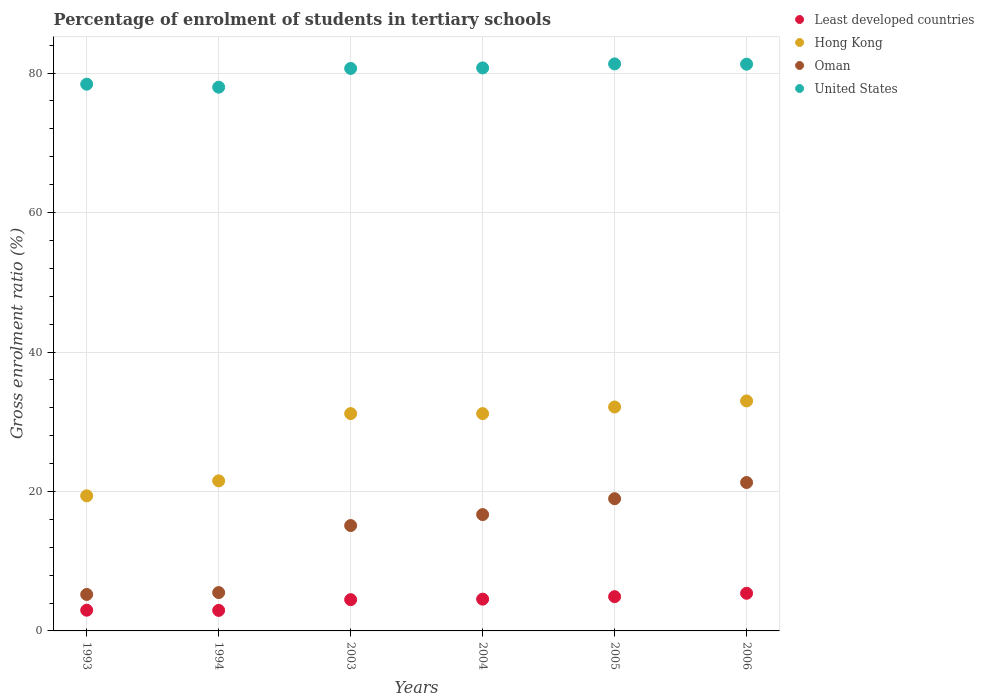How many different coloured dotlines are there?
Provide a succinct answer. 4. What is the percentage of students enrolled in tertiary schools in Least developed countries in 1993?
Make the answer very short. 2.97. Across all years, what is the maximum percentage of students enrolled in tertiary schools in United States?
Provide a succinct answer. 81.32. Across all years, what is the minimum percentage of students enrolled in tertiary schools in Oman?
Offer a terse response. 5.23. In which year was the percentage of students enrolled in tertiary schools in Hong Kong maximum?
Provide a succinct answer. 2006. In which year was the percentage of students enrolled in tertiary schools in Hong Kong minimum?
Provide a succinct answer. 1993. What is the total percentage of students enrolled in tertiary schools in United States in the graph?
Provide a short and direct response. 480.39. What is the difference between the percentage of students enrolled in tertiary schools in Least developed countries in 2003 and that in 2004?
Your response must be concise. -0.07. What is the difference between the percentage of students enrolled in tertiary schools in United States in 2006 and the percentage of students enrolled in tertiary schools in Hong Kong in 2004?
Give a very brief answer. 50.11. What is the average percentage of students enrolled in tertiary schools in Oman per year?
Ensure brevity in your answer.  13.79. In the year 2004, what is the difference between the percentage of students enrolled in tertiary schools in Least developed countries and percentage of students enrolled in tertiary schools in Hong Kong?
Keep it short and to the point. -26.61. In how many years, is the percentage of students enrolled in tertiary schools in Least developed countries greater than 4 %?
Your response must be concise. 4. What is the ratio of the percentage of students enrolled in tertiary schools in Oman in 2003 to that in 2006?
Your answer should be very brief. 0.71. Is the percentage of students enrolled in tertiary schools in Oman in 1993 less than that in 2006?
Your answer should be very brief. Yes. What is the difference between the highest and the second highest percentage of students enrolled in tertiary schools in Hong Kong?
Offer a very short reply. 0.87. What is the difference between the highest and the lowest percentage of students enrolled in tertiary schools in Least developed countries?
Ensure brevity in your answer.  2.46. In how many years, is the percentage of students enrolled in tertiary schools in Oman greater than the average percentage of students enrolled in tertiary schools in Oman taken over all years?
Your response must be concise. 4. Is the sum of the percentage of students enrolled in tertiary schools in Oman in 2003 and 2006 greater than the maximum percentage of students enrolled in tertiary schools in United States across all years?
Give a very brief answer. No. Does the percentage of students enrolled in tertiary schools in Hong Kong monotonically increase over the years?
Offer a terse response. No. Is the percentage of students enrolled in tertiary schools in Least developed countries strictly less than the percentage of students enrolled in tertiary schools in Oman over the years?
Your response must be concise. Yes. How many years are there in the graph?
Provide a short and direct response. 6. What is the difference between two consecutive major ticks on the Y-axis?
Your answer should be very brief. 20. Are the values on the major ticks of Y-axis written in scientific E-notation?
Your answer should be very brief. No. How are the legend labels stacked?
Your answer should be compact. Vertical. What is the title of the graph?
Offer a terse response. Percentage of enrolment of students in tertiary schools. What is the Gross enrolment ratio (%) in Least developed countries in 1993?
Provide a succinct answer. 2.97. What is the Gross enrolment ratio (%) of Hong Kong in 1993?
Provide a short and direct response. 19.37. What is the Gross enrolment ratio (%) in Oman in 1993?
Ensure brevity in your answer.  5.23. What is the Gross enrolment ratio (%) in United States in 1993?
Offer a very short reply. 78.41. What is the Gross enrolment ratio (%) in Least developed countries in 1994?
Your answer should be very brief. 2.94. What is the Gross enrolment ratio (%) of Hong Kong in 1994?
Make the answer very short. 21.52. What is the Gross enrolment ratio (%) in Oman in 1994?
Ensure brevity in your answer.  5.5. What is the Gross enrolment ratio (%) in United States in 1994?
Keep it short and to the point. 77.98. What is the Gross enrolment ratio (%) of Least developed countries in 2003?
Offer a very short reply. 4.48. What is the Gross enrolment ratio (%) of Hong Kong in 2003?
Give a very brief answer. 31.17. What is the Gross enrolment ratio (%) of Oman in 2003?
Provide a succinct answer. 15.11. What is the Gross enrolment ratio (%) in United States in 2003?
Your response must be concise. 80.66. What is the Gross enrolment ratio (%) in Least developed countries in 2004?
Offer a very short reply. 4.56. What is the Gross enrolment ratio (%) in Hong Kong in 2004?
Provide a short and direct response. 31.16. What is the Gross enrolment ratio (%) of Oman in 2004?
Offer a very short reply. 16.68. What is the Gross enrolment ratio (%) of United States in 2004?
Your response must be concise. 80.74. What is the Gross enrolment ratio (%) of Least developed countries in 2005?
Offer a terse response. 4.91. What is the Gross enrolment ratio (%) in Hong Kong in 2005?
Provide a short and direct response. 32.12. What is the Gross enrolment ratio (%) in Oman in 2005?
Offer a terse response. 18.96. What is the Gross enrolment ratio (%) in United States in 2005?
Give a very brief answer. 81.32. What is the Gross enrolment ratio (%) in Least developed countries in 2006?
Provide a short and direct response. 5.4. What is the Gross enrolment ratio (%) of Hong Kong in 2006?
Offer a very short reply. 32.98. What is the Gross enrolment ratio (%) of Oman in 2006?
Ensure brevity in your answer.  21.28. What is the Gross enrolment ratio (%) in United States in 2006?
Give a very brief answer. 81.28. Across all years, what is the maximum Gross enrolment ratio (%) in Least developed countries?
Your response must be concise. 5.4. Across all years, what is the maximum Gross enrolment ratio (%) of Hong Kong?
Give a very brief answer. 32.98. Across all years, what is the maximum Gross enrolment ratio (%) of Oman?
Offer a terse response. 21.28. Across all years, what is the maximum Gross enrolment ratio (%) in United States?
Your answer should be compact. 81.32. Across all years, what is the minimum Gross enrolment ratio (%) in Least developed countries?
Provide a short and direct response. 2.94. Across all years, what is the minimum Gross enrolment ratio (%) of Hong Kong?
Keep it short and to the point. 19.37. Across all years, what is the minimum Gross enrolment ratio (%) of Oman?
Provide a short and direct response. 5.23. Across all years, what is the minimum Gross enrolment ratio (%) in United States?
Your answer should be compact. 77.98. What is the total Gross enrolment ratio (%) of Least developed countries in the graph?
Give a very brief answer. 25.27. What is the total Gross enrolment ratio (%) of Hong Kong in the graph?
Make the answer very short. 168.33. What is the total Gross enrolment ratio (%) in Oman in the graph?
Your response must be concise. 82.77. What is the total Gross enrolment ratio (%) in United States in the graph?
Provide a short and direct response. 480.39. What is the difference between the Gross enrolment ratio (%) in Least developed countries in 1993 and that in 1994?
Provide a short and direct response. 0.03. What is the difference between the Gross enrolment ratio (%) in Hong Kong in 1993 and that in 1994?
Offer a terse response. -2.15. What is the difference between the Gross enrolment ratio (%) of Oman in 1993 and that in 1994?
Your answer should be compact. -0.27. What is the difference between the Gross enrolment ratio (%) of United States in 1993 and that in 1994?
Make the answer very short. 0.43. What is the difference between the Gross enrolment ratio (%) of Least developed countries in 1993 and that in 2003?
Make the answer very short. -1.51. What is the difference between the Gross enrolment ratio (%) of Hong Kong in 1993 and that in 2003?
Provide a succinct answer. -11.79. What is the difference between the Gross enrolment ratio (%) of Oman in 1993 and that in 2003?
Your answer should be compact. -9.88. What is the difference between the Gross enrolment ratio (%) of United States in 1993 and that in 2003?
Ensure brevity in your answer.  -2.25. What is the difference between the Gross enrolment ratio (%) in Least developed countries in 1993 and that in 2004?
Offer a terse response. -1.58. What is the difference between the Gross enrolment ratio (%) in Hong Kong in 1993 and that in 2004?
Your answer should be compact. -11.79. What is the difference between the Gross enrolment ratio (%) in Oman in 1993 and that in 2004?
Give a very brief answer. -11.45. What is the difference between the Gross enrolment ratio (%) of United States in 1993 and that in 2004?
Keep it short and to the point. -2.33. What is the difference between the Gross enrolment ratio (%) in Least developed countries in 1993 and that in 2005?
Offer a terse response. -1.94. What is the difference between the Gross enrolment ratio (%) of Hong Kong in 1993 and that in 2005?
Make the answer very short. -12.74. What is the difference between the Gross enrolment ratio (%) of Oman in 1993 and that in 2005?
Keep it short and to the point. -13.73. What is the difference between the Gross enrolment ratio (%) of United States in 1993 and that in 2005?
Offer a terse response. -2.91. What is the difference between the Gross enrolment ratio (%) in Least developed countries in 1993 and that in 2006?
Provide a succinct answer. -2.43. What is the difference between the Gross enrolment ratio (%) in Hong Kong in 1993 and that in 2006?
Offer a very short reply. -13.61. What is the difference between the Gross enrolment ratio (%) in Oman in 1993 and that in 2006?
Your response must be concise. -16.05. What is the difference between the Gross enrolment ratio (%) of United States in 1993 and that in 2006?
Offer a terse response. -2.87. What is the difference between the Gross enrolment ratio (%) in Least developed countries in 1994 and that in 2003?
Provide a short and direct response. -1.54. What is the difference between the Gross enrolment ratio (%) in Hong Kong in 1994 and that in 2003?
Offer a terse response. -9.65. What is the difference between the Gross enrolment ratio (%) of Oman in 1994 and that in 2003?
Keep it short and to the point. -9.61. What is the difference between the Gross enrolment ratio (%) of United States in 1994 and that in 2003?
Ensure brevity in your answer.  -2.69. What is the difference between the Gross enrolment ratio (%) of Least developed countries in 1994 and that in 2004?
Provide a succinct answer. -1.61. What is the difference between the Gross enrolment ratio (%) in Hong Kong in 1994 and that in 2004?
Give a very brief answer. -9.64. What is the difference between the Gross enrolment ratio (%) in Oman in 1994 and that in 2004?
Make the answer very short. -11.18. What is the difference between the Gross enrolment ratio (%) in United States in 1994 and that in 2004?
Keep it short and to the point. -2.76. What is the difference between the Gross enrolment ratio (%) of Least developed countries in 1994 and that in 2005?
Your answer should be compact. -1.97. What is the difference between the Gross enrolment ratio (%) in Hong Kong in 1994 and that in 2005?
Make the answer very short. -10.59. What is the difference between the Gross enrolment ratio (%) in Oman in 1994 and that in 2005?
Make the answer very short. -13.46. What is the difference between the Gross enrolment ratio (%) of United States in 1994 and that in 2005?
Make the answer very short. -3.34. What is the difference between the Gross enrolment ratio (%) of Least developed countries in 1994 and that in 2006?
Keep it short and to the point. -2.46. What is the difference between the Gross enrolment ratio (%) in Hong Kong in 1994 and that in 2006?
Make the answer very short. -11.46. What is the difference between the Gross enrolment ratio (%) in Oman in 1994 and that in 2006?
Give a very brief answer. -15.78. What is the difference between the Gross enrolment ratio (%) of United States in 1994 and that in 2006?
Your answer should be compact. -3.3. What is the difference between the Gross enrolment ratio (%) of Least developed countries in 2003 and that in 2004?
Provide a short and direct response. -0.07. What is the difference between the Gross enrolment ratio (%) of Hong Kong in 2003 and that in 2004?
Ensure brevity in your answer.  0. What is the difference between the Gross enrolment ratio (%) in Oman in 2003 and that in 2004?
Your response must be concise. -1.57. What is the difference between the Gross enrolment ratio (%) in United States in 2003 and that in 2004?
Make the answer very short. -0.08. What is the difference between the Gross enrolment ratio (%) in Least developed countries in 2003 and that in 2005?
Offer a terse response. -0.43. What is the difference between the Gross enrolment ratio (%) in Hong Kong in 2003 and that in 2005?
Your response must be concise. -0.95. What is the difference between the Gross enrolment ratio (%) of Oman in 2003 and that in 2005?
Offer a very short reply. -3.85. What is the difference between the Gross enrolment ratio (%) in United States in 2003 and that in 2005?
Offer a terse response. -0.65. What is the difference between the Gross enrolment ratio (%) of Least developed countries in 2003 and that in 2006?
Ensure brevity in your answer.  -0.92. What is the difference between the Gross enrolment ratio (%) of Hong Kong in 2003 and that in 2006?
Keep it short and to the point. -1.82. What is the difference between the Gross enrolment ratio (%) of Oman in 2003 and that in 2006?
Offer a terse response. -6.17. What is the difference between the Gross enrolment ratio (%) in United States in 2003 and that in 2006?
Offer a terse response. -0.61. What is the difference between the Gross enrolment ratio (%) in Least developed countries in 2004 and that in 2005?
Provide a short and direct response. -0.36. What is the difference between the Gross enrolment ratio (%) of Hong Kong in 2004 and that in 2005?
Offer a terse response. -0.95. What is the difference between the Gross enrolment ratio (%) of Oman in 2004 and that in 2005?
Your answer should be compact. -2.28. What is the difference between the Gross enrolment ratio (%) in United States in 2004 and that in 2005?
Make the answer very short. -0.57. What is the difference between the Gross enrolment ratio (%) in Least developed countries in 2004 and that in 2006?
Your answer should be compact. -0.84. What is the difference between the Gross enrolment ratio (%) in Hong Kong in 2004 and that in 2006?
Your answer should be very brief. -1.82. What is the difference between the Gross enrolment ratio (%) of Oman in 2004 and that in 2006?
Ensure brevity in your answer.  -4.6. What is the difference between the Gross enrolment ratio (%) of United States in 2004 and that in 2006?
Offer a terse response. -0.54. What is the difference between the Gross enrolment ratio (%) of Least developed countries in 2005 and that in 2006?
Provide a succinct answer. -0.49. What is the difference between the Gross enrolment ratio (%) in Hong Kong in 2005 and that in 2006?
Your answer should be compact. -0.87. What is the difference between the Gross enrolment ratio (%) in Oman in 2005 and that in 2006?
Your response must be concise. -2.32. What is the difference between the Gross enrolment ratio (%) in United States in 2005 and that in 2006?
Your response must be concise. 0.04. What is the difference between the Gross enrolment ratio (%) in Least developed countries in 1993 and the Gross enrolment ratio (%) in Hong Kong in 1994?
Ensure brevity in your answer.  -18.55. What is the difference between the Gross enrolment ratio (%) in Least developed countries in 1993 and the Gross enrolment ratio (%) in Oman in 1994?
Offer a very short reply. -2.53. What is the difference between the Gross enrolment ratio (%) in Least developed countries in 1993 and the Gross enrolment ratio (%) in United States in 1994?
Your answer should be very brief. -75.01. What is the difference between the Gross enrolment ratio (%) of Hong Kong in 1993 and the Gross enrolment ratio (%) of Oman in 1994?
Make the answer very short. 13.87. What is the difference between the Gross enrolment ratio (%) in Hong Kong in 1993 and the Gross enrolment ratio (%) in United States in 1994?
Provide a short and direct response. -58.6. What is the difference between the Gross enrolment ratio (%) in Oman in 1993 and the Gross enrolment ratio (%) in United States in 1994?
Provide a short and direct response. -72.75. What is the difference between the Gross enrolment ratio (%) in Least developed countries in 1993 and the Gross enrolment ratio (%) in Hong Kong in 2003?
Your answer should be very brief. -28.2. What is the difference between the Gross enrolment ratio (%) in Least developed countries in 1993 and the Gross enrolment ratio (%) in Oman in 2003?
Provide a succinct answer. -12.14. What is the difference between the Gross enrolment ratio (%) in Least developed countries in 1993 and the Gross enrolment ratio (%) in United States in 2003?
Ensure brevity in your answer.  -77.69. What is the difference between the Gross enrolment ratio (%) of Hong Kong in 1993 and the Gross enrolment ratio (%) of Oman in 2003?
Your answer should be very brief. 4.26. What is the difference between the Gross enrolment ratio (%) in Hong Kong in 1993 and the Gross enrolment ratio (%) in United States in 2003?
Provide a succinct answer. -61.29. What is the difference between the Gross enrolment ratio (%) of Oman in 1993 and the Gross enrolment ratio (%) of United States in 2003?
Keep it short and to the point. -75.43. What is the difference between the Gross enrolment ratio (%) of Least developed countries in 1993 and the Gross enrolment ratio (%) of Hong Kong in 2004?
Offer a terse response. -28.19. What is the difference between the Gross enrolment ratio (%) of Least developed countries in 1993 and the Gross enrolment ratio (%) of Oman in 2004?
Keep it short and to the point. -13.71. What is the difference between the Gross enrolment ratio (%) of Least developed countries in 1993 and the Gross enrolment ratio (%) of United States in 2004?
Your answer should be very brief. -77.77. What is the difference between the Gross enrolment ratio (%) in Hong Kong in 1993 and the Gross enrolment ratio (%) in Oman in 2004?
Make the answer very short. 2.69. What is the difference between the Gross enrolment ratio (%) of Hong Kong in 1993 and the Gross enrolment ratio (%) of United States in 2004?
Your response must be concise. -61.37. What is the difference between the Gross enrolment ratio (%) in Oman in 1993 and the Gross enrolment ratio (%) in United States in 2004?
Provide a short and direct response. -75.51. What is the difference between the Gross enrolment ratio (%) in Least developed countries in 1993 and the Gross enrolment ratio (%) in Hong Kong in 2005?
Give a very brief answer. -29.14. What is the difference between the Gross enrolment ratio (%) of Least developed countries in 1993 and the Gross enrolment ratio (%) of Oman in 2005?
Ensure brevity in your answer.  -15.99. What is the difference between the Gross enrolment ratio (%) in Least developed countries in 1993 and the Gross enrolment ratio (%) in United States in 2005?
Ensure brevity in your answer.  -78.35. What is the difference between the Gross enrolment ratio (%) of Hong Kong in 1993 and the Gross enrolment ratio (%) of Oman in 2005?
Offer a terse response. 0.41. What is the difference between the Gross enrolment ratio (%) of Hong Kong in 1993 and the Gross enrolment ratio (%) of United States in 2005?
Your answer should be very brief. -61.94. What is the difference between the Gross enrolment ratio (%) of Oman in 1993 and the Gross enrolment ratio (%) of United States in 2005?
Provide a succinct answer. -76.09. What is the difference between the Gross enrolment ratio (%) in Least developed countries in 1993 and the Gross enrolment ratio (%) in Hong Kong in 2006?
Keep it short and to the point. -30.01. What is the difference between the Gross enrolment ratio (%) of Least developed countries in 1993 and the Gross enrolment ratio (%) of Oman in 2006?
Offer a very short reply. -18.31. What is the difference between the Gross enrolment ratio (%) in Least developed countries in 1993 and the Gross enrolment ratio (%) in United States in 2006?
Your response must be concise. -78.31. What is the difference between the Gross enrolment ratio (%) in Hong Kong in 1993 and the Gross enrolment ratio (%) in Oman in 2006?
Ensure brevity in your answer.  -1.91. What is the difference between the Gross enrolment ratio (%) of Hong Kong in 1993 and the Gross enrolment ratio (%) of United States in 2006?
Keep it short and to the point. -61.9. What is the difference between the Gross enrolment ratio (%) in Oman in 1993 and the Gross enrolment ratio (%) in United States in 2006?
Ensure brevity in your answer.  -76.05. What is the difference between the Gross enrolment ratio (%) of Least developed countries in 1994 and the Gross enrolment ratio (%) of Hong Kong in 2003?
Offer a very short reply. -28.22. What is the difference between the Gross enrolment ratio (%) of Least developed countries in 1994 and the Gross enrolment ratio (%) of Oman in 2003?
Keep it short and to the point. -12.17. What is the difference between the Gross enrolment ratio (%) of Least developed countries in 1994 and the Gross enrolment ratio (%) of United States in 2003?
Offer a terse response. -77.72. What is the difference between the Gross enrolment ratio (%) in Hong Kong in 1994 and the Gross enrolment ratio (%) in Oman in 2003?
Offer a very short reply. 6.41. What is the difference between the Gross enrolment ratio (%) in Hong Kong in 1994 and the Gross enrolment ratio (%) in United States in 2003?
Give a very brief answer. -59.14. What is the difference between the Gross enrolment ratio (%) of Oman in 1994 and the Gross enrolment ratio (%) of United States in 2003?
Your answer should be very brief. -75.16. What is the difference between the Gross enrolment ratio (%) in Least developed countries in 1994 and the Gross enrolment ratio (%) in Hong Kong in 2004?
Provide a short and direct response. -28.22. What is the difference between the Gross enrolment ratio (%) of Least developed countries in 1994 and the Gross enrolment ratio (%) of Oman in 2004?
Ensure brevity in your answer.  -13.74. What is the difference between the Gross enrolment ratio (%) of Least developed countries in 1994 and the Gross enrolment ratio (%) of United States in 2004?
Offer a terse response. -77.8. What is the difference between the Gross enrolment ratio (%) of Hong Kong in 1994 and the Gross enrolment ratio (%) of Oman in 2004?
Provide a short and direct response. 4.84. What is the difference between the Gross enrolment ratio (%) in Hong Kong in 1994 and the Gross enrolment ratio (%) in United States in 2004?
Offer a very short reply. -59.22. What is the difference between the Gross enrolment ratio (%) in Oman in 1994 and the Gross enrolment ratio (%) in United States in 2004?
Ensure brevity in your answer.  -75.24. What is the difference between the Gross enrolment ratio (%) in Least developed countries in 1994 and the Gross enrolment ratio (%) in Hong Kong in 2005?
Keep it short and to the point. -29.17. What is the difference between the Gross enrolment ratio (%) of Least developed countries in 1994 and the Gross enrolment ratio (%) of Oman in 2005?
Your response must be concise. -16.02. What is the difference between the Gross enrolment ratio (%) of Least developed countries in 1994 and the Gross enrolment ratio (%) of United States in 2005?
Keep it short and to the point. -78.37. What is the difference between the Gross enrolment ratio (%) of Hong Kong in 1994 and the Gross enrolment ratio (%) of Oman in 2005?
Offer a terse response. 2.56. What is the difference between the Gross enrolment ratio (%) of Hong Kong in 1994 and the Gross enrolment ratio (%) of United States in 2005?
Your response must be concise. -59.8. What is the difference between the Gross enrolment ratio (%) in Oman in 1994 and the Gross enrolment ratio (%) in United States in 2005?
Give a very brief answer. -75.82. What is the difference between the Gross enrolment ratio (%) of Least developed countries in 1994 and the Gross enrolment ratio (%) of Hong Kong in 2006?
Make the answer very short. -30.04. What is the difference between the Gross enrolment ratio (%) in Least developed countries in 1994 and the Gross enrolment ratio (%) in Oman in 2006?
Your answer should be very brief. -18.34. What is the difference between the Gross enrolment ratio (%) in Least developed countries in 1994 and the Gross enrolment ratio (%) in United States in 2006?
Your answer should be compact. -78.33. What is the difference between the Gross enrolment ratio (%) of Hong Kong in 1994 and the Gross enrolment ratio (%) of Oman in 2006?
Your answer should be very brief. 0.24. What is the difference between the Gross enrolment ratio (%) in Hong Kong in 1994 and the Gross enrolment ratio (%) in United States in 2006?
Keep it short and to the point. -59.76. What is the difference between the Gross enrolment ratio (%) of Oman in 1994 and the Gross enrolment ratio (%) of United States in 2006?
Give a very brief answer. -75.78. What is the difference between the Gross enrolment ratio (%) of Least developed countries in 2003 and the Gross enrolment ratio (%) of Hong Kong in 2004?
Provide a succinct answer. -26.68. What is the difference between the Gross enrolment ratio (%) of Least developed countries in 2003 and the Gross enrolment ratio (%) of Oman in 2004?
Provide a short and direct response. -12.2. What is the difference between the Gross enrolment ratio (%) in Least developed countries in 2003 and the Gross enrolment ratio (%) in United States in 2004?
Provide a succinct answer. -76.26. What is the difference between the Gross enrolment ratio (%) in Hong Kong in 2003 and the Gross enrolment ratio (%) in Oman in 2004?
Offer a terse response. 14.48. What is the difference between the Gross enrolment ratio (%) of Hong Kong in 2003 and the Gross enrolment ratio (%) of United States in 2004?
Keep it short and to the point. -49.57. What is the difference between the Gross enrolment ratio (%) in Oman in 2003 and the Gross enrolment ratio (%) in United States in 2004?
Give a very brief answer. -65.63. What is the difference between the Gross enrolment ratio (%) in Least developed countries in 2003 and the Gross enrolment ratio (%) in Hong Kong in 2005?
Offer a very short reply. -27.63. What is the difference between the Gross enrolment ratio (%) of Least developed countries in 2003 and the Gross enrolment ratio (%) of Oman in 2005?
Give a very brief answer. -14.48. What is the difference between the Gross enrolment ratio (%) in Least developed countries in 2003 and the Gross enrolment ratio (%) in United States in 2005?
Provide a short and direct response. -76.83. What is the difference between the Gross enrolment ratio (%) of Hong Kong in 2003 and the Gross enrolment ratio (%) of Oman in 2005?
Offer a terse response. 12.21. What is the difference between the Gross enrolment ratio (%) in Hong Kong in 2003 and the Gross enrolment ratio (%) in United States in 2005?
Offer a terse response. -50.15. What is the difference between the Gross enrolment ratio (%) in Oman in 2003 and the Gross enrolment ratio (%) in United States in 2005?
Offer a very short reply. -66.21. What is the difference between the Gross enrolment ratio (%) in Least developed countries in 2003 and the Gross enrolment ratio (%) in Hong Kong in 2006?
Your response must be concise. -28.5. What is the difference between the Gross enrolment ratio (%) of Least developed countries in 2003 and the Gross enrolment ratio (%) of Oman in 2006?
Your answer should be very brief. -16.8. What is the difference between the Gross enrolment ratio (%) in Least developed countries in 2003 and the Gross enrolment ratio (%) in United States in 2006?
Provide a succinct answer. -76.8. What is the difference between the Gross enrolment ratio (%) in Hong Kong in 2003 and the Gross enrolment ratio (%) in Oman in 2006?
Ensure brevity in your answer.  9.88. What is the difference between the Gross enrolment ratio (%) of Hong Kong in 2003 and the Gross enrolment ratio (%) of United States in 2006?
Give a very brief answer. -50.11. What is the difference between the Gross enrolment ratio (%) of Oman in 2003 and the Gross enrolment ratio (%) of United States in 2006?
Keep it short and to the point. -66.17. What is the difference between the Gross enrolment ratio (%) in Least developed countries in 2004 and the Gross enrolment ratio (%) in Hong Kong in 2005?
Ensure brevity in your answer.  -27.56. What is the difference between the Gross enrolment ratio (%) in Least developed countries in 2004 and the Gross enrolment ratio (%) in Oman in 2005?
Give a very brief answer. -14.4. What is the difference between the Gross enrolment ratio (%) of Least developed countries in 2004 and the Gross enrolment ratio (%) of United States in 2005?
Offer a terse response. -76.76. What is the difference between the Gross enrolment ratio (%) in Hong Kong in 2004 and the Gross enrolment ratio (%) in Oman in 2005?
Your answer should be very brief. 12.2. What is the difference between the Gross enrolment ratio (%) in Hong Kong in 2004 and the Gross enrolment ratio (%) in United States in 2005?
Make the answer very short. -50.15. What is the difference between the Gross enrolment ratio (%) in Oman in 2004 and the Gross enrolment ratio (%) in United States in 2005?
Your response must be concise. -64.63. What is the difference between the Gross enrolment ratio (%) of Least developed countries in 2004 and the Gross enrolment ratio (%) of Hong Kong in 2006?
Provide a succinct answer. -28.43. What is the difference between the Gross enrolment ratio (%) in Least developed countries in 2004 and the Gross enrolment ratio (%) in Oman in 2006?
Offer a terse response. -16.73. What is the difference between the Gross enrolment ratio (%) of Least developed countries in 2004 and the Gross enrolment ratio (%) of United States in 2006?
Keep it short and to the point. -76.72. What is the difference between the Gross enrolment ratio (%) in Hong Kong in 2004 and the Gross enrolment ratio (%) in Oman in 2006?
Provide a short and direct response. 9.88. What is the difference between the Gross enrolment ratio (%) in Hong Kong in 2004 and the Gross enrolment ratio (%) in United States in 2006?
Your answer should be compact. -50.11. What is the difference between the Gross enrolment ratio (%) in Oman in 2004 and the Gross enrolment ratio (%) in United States in 2006?
Ensure brevity in your answer.  -64.59. What is the difference between the Gross enrolment ratio (%) in Least developed countries in 2005 and the Gross enrolment ratio (%) in Hong Kong in 2006?
Your answer should be very brief. -28.07. What is the difference between the Gross enrolment ratio (%) in Least developed countries in 2005 and the Gross enrolment ratio (%) in Oman in 2006?
Provide a succinct answer. -16.37. What is the difference between the Gross enrolment ratio (%) of Least developed countries in 2005 and the Gross enrolment ratio (%) of United States in 2006?
Give a very brief answer. -76.36. What is the difference between the Gross enrolment ratio (%) of Hong Kong in 2005 and the Gross enrolment ratio (%) of Oman in 2006?
Offer a terse response. 10.83. What is the difference between the Gross enrolment ratio (%) in Hong Kong in 2005 and the Gross enrolment ratio (%) in United States in 2006?
Your answer should be very brief. -49.16. What is the difference between the Gross enrolment ratio (%) in Oman in 2005 and the Gross enrolment ratio (%) in United States in 2006?
Make the answer very short. -62.32. What is the average Gross enrolment ratio (%) in Least developed countries per year?
Make the answer very short. 4.21. What is the average Gross enrolment ratio (%) in Hong Kong per year?
Offer a very short reply. 28.05. What is the average Gross enrolment ratio (%) in Oman per year?
Give a very brief answer. 13.79. What is the average Gross enrolment ratio (%) in United States per year?
Ensure brevity in your answer.  80.06. In the year 1993, what is the difference between the Gross enrolment ratio (%) of Least developed countries and Gross enrolment ratio (%) of Hong Kong?
Your response must be concise. -16.4. In the year 1993, what is the difference between the Gross enrolment ratio (%) of Least developed countries and Gross enrolment ratio (%) of Oman?
Ensure brevity in your answer.  -2.26. In the year 1993, what is the difference between the Gross enrolment ratio (%) of Least developed countries and Gross enrolment ratio (%) of United States?
Make the answer very short. -75.44. In the year 1993, what is the difference between the Gross enrolment ratio (%) of Hong Kong and Gross enrolment ratio (%) of Oman?
Offer a terse response. 14.14. In the year 1993, what is the difference between the Gross enrolment ratio (%) in Hong Kong and Gross enrolment ratio (%) in United States?
Ensure brevity in your answer.  -59.04. In the year 1993, what is the difference between the Gross enrolment ratio (%) of Oman and Gross enrolment ratio (%) of United States?
Make the answer very short. -73.18. In the year 1994, what is the difference between the Gross enrolment ratio (%) in Least developed countries and Gross enrolment ratio (%) in Hong Kong?
Your response must be concise. -18.58. In the year 1994, what is the difference between the Gross enrolment ratio (%) of Least developed countries and Gross enrolment ratio (%) of Oman?
Ensure brevity in your answer.  -2.56. In the year 1994, what is the difference between the Gross enrolment ratio (%) of Least developed countries and Gross enrolment ratio (%) of United States?
Your answer should be compact. -75.03. In the year 1994, what is the difference between the Gross enrolment ratio (%) of Hong Kong and Gross enrolment ratio (%) of Oman?
Offer a very short reply. 16.02. In the year 1994, what is the difference between the Gross enrolment ratio (%) in Hong Kong and Gross enrolment ratio (%) in United States?
Provide a succinct answer. -56.46. In the year 1994, what is the difference between the Gross enrolment ratio (%) in Oman and Gross enrolment ratio (%) in United States?
Your answer should be compact. -72.48. In the year 2003, what is the difference between the Gross enrolment ratio (%) in Least developed countries and Gross enrolment ratio (%) in Hong Kong?
Provide a short and direct response. -26.68. In the year 2003, what is the difference between the Gross enrolment ratio (%) of Least developed countries and Gross enrolment ratio (%) of Oman?
Your response must be concise. -10.63. In the year 2003, what is the difference between the Gross enrolment ratio (%) of Least developed countries and Gross enrolment ratio (%) of United States?
Ensure brevity in your answer.  -76.18. In the year 2003, what is the difference between the Gross enrolment ratio (%) in Hong Kong and Gross enrolment ratio (%) in Oman?
Ensure brevity in your answer.  16.06. In the year 2003, what is the difference between the Gross enrolment ratio (%) of Hong Kong and Gross enrolment ratio (%) of United States?
Your response must be concise. -49.5. In the year 2003, what is the difference between the Gross enrolment ratio (%) of Oman and Gross enrolment ratio (%) of United States?
Offer a terse response. -65.55. In the year 2004, what is the difference between the Gross enrolment ratio (%) in Least developed countries and Gross enrolment ratio (%) in Hong Kong?
Your response must be concise. -26.61. In the year 2004, what is the difference between the Gross enrolment ratio (%) of Least developed countries and Gross enrolment ratio (%) of Oman?
Your answer should be compact. -12.13. In the year 2004, what is the difference between the Gross enrolment ratio (%) in Least developed countries and Gross enrolment ratio (%) in United States?
Your response must be concise. -76.19. In the year 2004, what is the difference between the Gross enrolment ratio (%) of Hong Kong and Gross enrolment ratio (%) of Oman?
Ensure brevity in your answer.  14.48. In the year 2004, what is the difference between the Gross enrolment ratio (%) of Hong Kong and Gross enrolment ratio (%) of United States?
Provide a succinct answer. -49.58. In the year 2004, what is the difference between the Gross enrolment ratio (%) of Oman and Gross enrolment ratio (%) of United States?
Provide a succinct answer. -64.06. In the year 2005, what is the difference between the Gross enrolment ratio (%) of Least developed countries and Gross enrolment ratio (%) of Hong Kong?
Offer a very short reply. -27.2. In the year 2005, what is the difference between the Gross enrolment ratio (%) in Least developed countries and Gross enrolment ratio (%) in Oman?
Give a very brief answer. -14.05. In the year 2005, what is the difference between the Gross enrolment ratio (%) in Least developed countries and Gross enrolment ratio (%) in United States?
Provide a succinct answer. -76.4. In the year 2005, what is the difference between the Gross enrolment ratio (%) of Hong Kong and Gross enrolment ratio (%) of Oman?
Your answer should be compact. 13.16. In the year 2005, what is the difference between the Gross enrolment ratio (%) in Hong Kong and Gross enrolment ratio (%) in United States?
Provide a short and direct response. -49.2. In the year 2005, what is the difference between the Gross enrolment ratio (%) of Oman and Gross enrolment ratio (%) of United States?
Ensure brevity in your answer.  -62.36. In the year 2006, what is the difference between the Gross enrolment ratio (%) of Least developed countries and Gross enrolment ratio (%) of Hong Kong?
Your answer should be compact. -27.59. In the year 2006, what is the difference between the Gross enrolment ratio (%) of Least developed countries and Gross enrolment ratio (%) of Oman?
Provide a short and direct response. -15.88. In the year 2006, what is the difference between the Gross enrolment ratio (%) of Least developed countries and Gross enrolment ratio (%) of United States?
Ensure brevity in your answer.  -75.88. In the year 2006, what is the difference between the Gross enrolment ratio (%) of Hong Kong and Gross enrolment ratio (%) of Oman?
Keep it short and to the point. 11.7. In the year 2006, what is the difference between the Gross enrolment ratio (%) of Hong Kong and Gross enrolment ratio (%) of United States?
Offer a terse response. -48.29. In the year 2006, what is the difference between the Gross enrolment ratio (%) of Oman and Gross enrolment ratio (%) of United States?
Provide a succinct answer. -59.99. What is the ratio of the Gross enrolment ratio (%) in Least developed countries in 1993 to that in 1994?
Your response must be concise. 1.01. What is the ratio of the Gross enrolment ratio (%) in Hong Kong in 1993 to that in 1994?
Give a very brief answer. 0.9. What is the ratio of the Gross enrolment ratio (%) of Oman in 1993 to that in 1994?
Keep it short and to the point. 0.95. What is the ratio of the Gross enrolment ratio (%) in United States in 1993 to that in 1994?
Make the answer very short. 1.01. What is the ratio of the Gross enrolment ratio (%) in Least developed countries in 1993 to that in 2003?
Make the answer very short. 0.66. What is the ratio of the Gross enrolment ratio (%) in Hong Kong in 1993 to that in 2003?
Give a very brief answer. 0.62. What is the ratio of the Gross enrolment ratio (%) in Oman in 1993 to that in 2003?
Your response must be concise. 0.35. What is the ratio of the Gross enrolment ratio (%) in United States in 1993 to that in 2003?
Your answer should be very brief. 0.97. What is the ratio of the Gross enrolment ratio (%) in Least developed countries in 1993 to that in 2004?
Provide a succinct answer. 0.65. What is the ratio of the Gross enrolment ratio (%) of Hong Kong in 1993 to that in 2004?
Keep it short and to the point. 0.62. What is the ratio of the Gross enrolment ratio (%) of Oman in 1993 to that in 2004?
Your answer should be compact. 0.31. What is the ratio of the Gross enrolment ratio (%) in United States in 1993 to that in 2004?
Give a very brief answer. 0.97. What is the ratio of the Gross enrolment ratio (%) of Least developed countries in 1993 to that in 2005?
Keep it short and to the point. 0.6. What is the ratio of the Gross enrolment ratio (%) in Hong Kong in 1993 to that in 2005?
Your answer should be compact. 0.6. What is the ratio of the Gross enrolment ratio (%) in Oman in 1993 to that in 2005?
Make the answer very short. 0.28. What is the ratio of the Gross enrolment ratio (%) in Least developed countries in 1993 to that in 2006?
Keep it short and to the point. 0.55. What is the ratio of the Gross enrolment ratio (%) of Hong Kong in 1993 to that in 2006?
Your response must be concise. 0.59. What is the ratio of the Gross enrolment ratio (%) in Oman in 1993 to that in 2006?
Make the answer very short. 0.25. What is the ratio of the Gross enrolment ratio (%) of United States in 1993 to that in 2006?
Provide a succinct answer. 0.96. What is the ratio of the Gross enrolment ratio (%) in Least developed countries in 1994 to that in 2003?
Make the answer very short. 0.66. What is the ratio of the Gross enrolment ratio (%) of Hong Kong in 1994 to that in 2003?
Keep it short and to the point. 0.69. What is the ratio of the Gross enrolment ratio (%) of Oman in 1994 to that in 2003?
Give a very brief answer. 0.36. What is the ratio of the Gross enrolment ratio (%) of United States in 1994 to that in 2003?
Offer a terse response. 0.97. What is the ratio of the Gross enrolment ratio (%) of Least developed countries in 1994 to that in 2004?
Make the answer very short. 0.65. What is the ratio of the Gross enrolment ratio (%) of Hong Kong in 1994 to that in 2004?
Your answer should be compact. 0.69. What is the ratio of the Gross enrolment ratio (%) in Oman in 1994 to that in 2004?
Your answer should be compact. 0.33. What is the ratio of the Gross enrolment ratio (%) in United States in 1994 to that in 2004?
Ensure brevity in your answer.  0.97. What is the ratio of the Gross enrolment ratio (%) of Least developed countries in 1994 to that in 2005?
Your response must be concise. 0.6. What is the ratio of the Gross enrolment ratio (%) of Hong Kong in 1994 to that in 2005?
Your response must be concise. 0.67. What is the ratio of the Gross enrolment ratio (%) of Oman in 1994 to that in 2005?
Make the answer very short. 0.29. What is the ratio of the Gross enrolment ratio (%) of United States in 1994 to that in 2005?
Offer a very short reply. 0.96. What is the ratio of the Gross enrolment ratio (%) in Least developed countries in 1994 to that in 2006?
Provide a succinct answer. 0.55. What is the ratio of the Gross enrolment ratio (%) in Hong Kong in 1994 to that in 2006?
Your answer should be very brief. 0.65. What is the ratio of the Gross enrolment ratio (%) of Oman in 1994 to that in 2006?
Provide a short and direct response. 0.26. What is the ratio of the Gross enrolment ratio (%) in United States in 1994 to that in 2006?
Your answer should be compact. 0.96. What is the ratio of the Gross enrolment ratio (%) in Least developed countries in 2003 to that in 2004?
Ensure brevity in your answer.  0.98. What is the ratio of the Gross enrolment ratio (%) of Oman in 2003 to that in 2004?
Give a very brief answer. 0.91. What is the ratio of the Gross enrolment ratio (%) in Least developed countries in 2003 to that in 2005?
Give a very brief answer. 0.91. What is the ratio of the Gross enrolment ratio (%) of Hong Kong in 2003 to that in 2005?
Your response must be concise. 0.97. What is the ratio of the Gross enrolment ratio (%) of Oman in 2003 to that in 2005?
Make the answer very short. 0.8. What is the ratio of the Gross enrolment ratio (%) in Least developed countries in 2003 to that in 2006?
Make the answer very short. 0.83. What is the ratio of the Gross enrolment ratio (%) of Hong Kong in 2003 to that in 2006?
Make the answer very short. 0.94. What is the ratio of the Gross enrolment ratio (%) of Oman in 2003 to that in 2006?
Offer a terse response. 0.71. What is the ratio of the Gross enrolment ratio (%) of Least developed countries in 2004 to that in 2005?
Offer a terse response. 0.93. What is the ratio of the Gross enrolment ratio (%) in Hong Kong in 2004 to that in 2005?
Your answer should be compact. 0.97. What is the ratio of the Gross enrolment ratio (%) of Oman in 2004 to that in 2005?
Ensure brevity in your answer.  0.88. What is the ratio of the Gross enrolment ratio (%) of United States in 2004 to that in 2005?
Make the answer very short. 0.99. What is the ratio of the Gross enrolment ratio (%) of Least developed countries in 2004 to that in 2006?
Your response must be concise. 0.84. What is the ratio of the Gross enrolment ratio (%) of Hong Kong in 2004 to that in 2006?
Ensure brevity in your answer.  0.94. What is the ratio of the Gross enrolment ratio (%) in Oman in 2004 to that in 2006?
Your answer should be compact. 0.78. What is the ratio of the Gross enrolment ratio (%) of Least developed countries in 2005 to that in 2006?
Provide a succinct answer. 0.91. What is the ratio of the Gross enrolment ratio (%) in Hong Kong in 2005 to that in 2006?
Your response must be concise. 0.97. What is the ratio of the Gross enrolment ratio (%) of Oman in 2005 to that in 2006?
Provide a short and direct response. 0.89. What is the difference between the highest and the second highest Gross enrolment ratio (%) of Least developed countries?
Keep it short and to the point. 0.49. What is the difference between the highest and the second highest Gross enrolment ratio (%) of Hong Kong?
Your answer should be very brief. 0.87. What is the difference between the highest and the second highest Gross enrolment ratio (%) of Oman?
Provide a short and direct response. 2.32. What is the difference between the highest and the second highest Gross enrolment ratio (%) in United States?
Keep it short and to the point. 0.04. What is the difference between the highest and the lowest Gross enrolment ratio (%) in Least developed countries?
Give a very brief answer. 2.46. What is the difference between the highest and the lowest Gross enrolment ratio (%) of Hong Kong?
Your answer should be compact. 13.61. What is the difference between the highest and the lowest Gross enrolment ratio (%) in Oman?
Your answer should be compact. 16.05. What is the difference between the highest and the lowest Gross enrolment ratio (%) of United States?
Your answer should be compact. 3.34. 